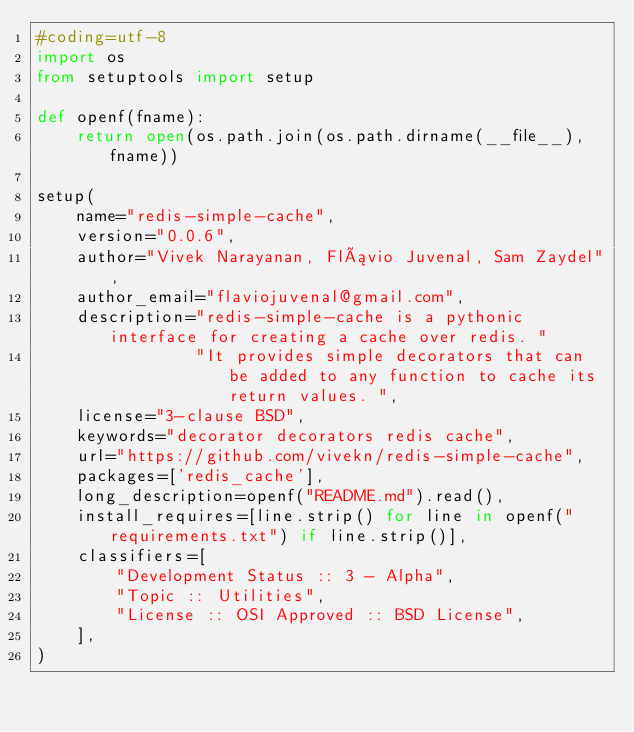<code> <loc_0><loc_0><loc_500><loc_500><_Python_>#coding=utf-8
import os
from setuptools import setup

def openf(fname):
    return open(os.path.join(os.path.dirname(__file__), fname))

setup(
    name="redis-simple-cache",
    version="0.0.6",
    author="Vivek Narayanan, Flávio Juvenal, Sam Zaydel",
    author_email="flaviojuvenal@gmail.com",
    description="redis-simple-cache is a pythonic interface for creating a cache over redis. "
                "It provides simple decorators that can be added to any function to cache its return values. ",
    license="3-clause BSD",
    keywords="decorator decorators redis cache",
    url="https://github.com/vivekn/redis-simple-cache",
    packages=['redis_cache'],
    long_description=openf("README.md").read(),
    install_requires=[line.strip() for line in openf("requirements.txt") if line.strip()],
    classifiers=[
        "Development Status :: 3 - Alpha",
        "Topic :: Utilities",
        "License :: OSI Approved :: BSD License",
    ],
)
</code> 